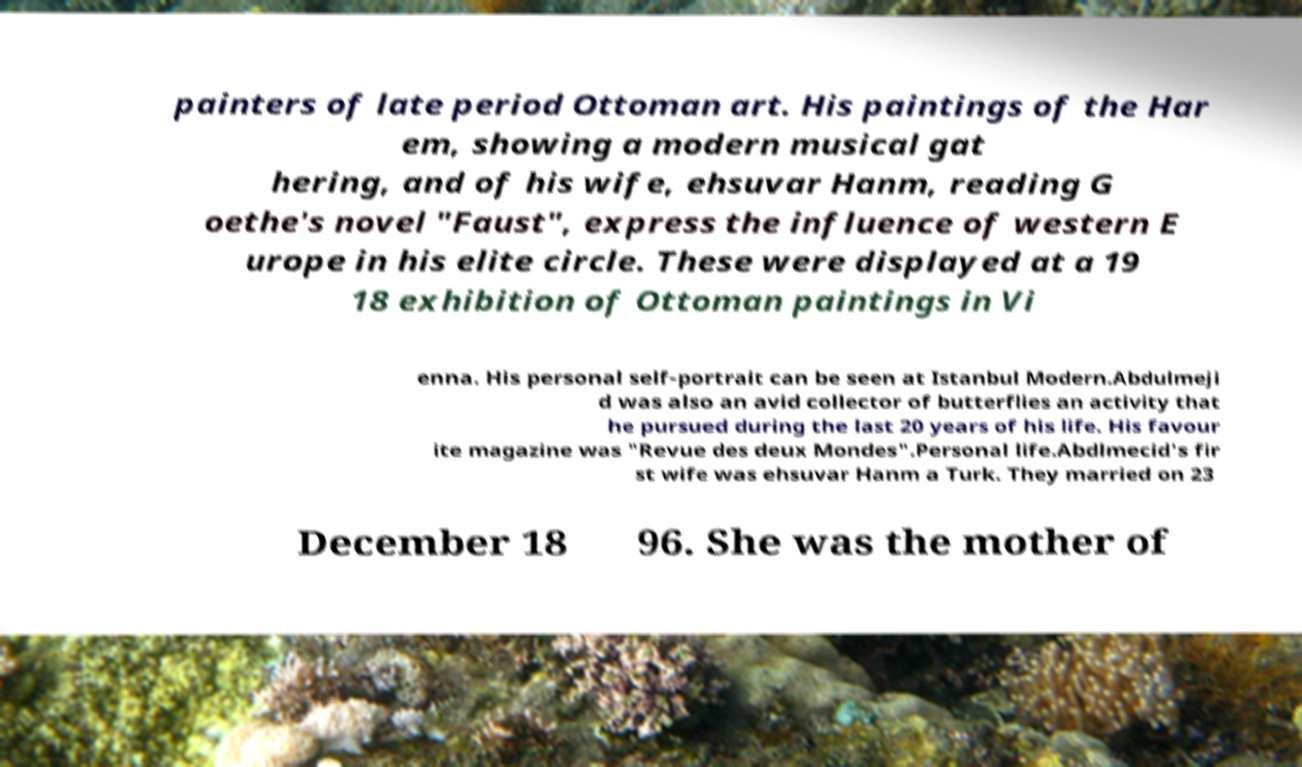Can you accurately transcribe the text from the provided image for me? painters of late period Ottoman art. His paintings of the Har em, showing a modern musical gat hering, and of his wife, ehsuvar Hanm, reading G oethe's novel "Faust", express the influence of western E urope in his elite circle. These were displayed at a 19 18 exhibition of Ottoman paintings in Vi enna. His personal self-portrait can be seen at Istanbul Modern.Abdulmeji d was also an avid collector of butterflies an activity that he pursued during the last 20 years of his life. His favour ite magazine was "Revue des deux Mondes".Personal life.Abdlmecid's fir st wife was ehsuvar Hanm a Turk. They married on 23 December 18 96. She was the mother of 